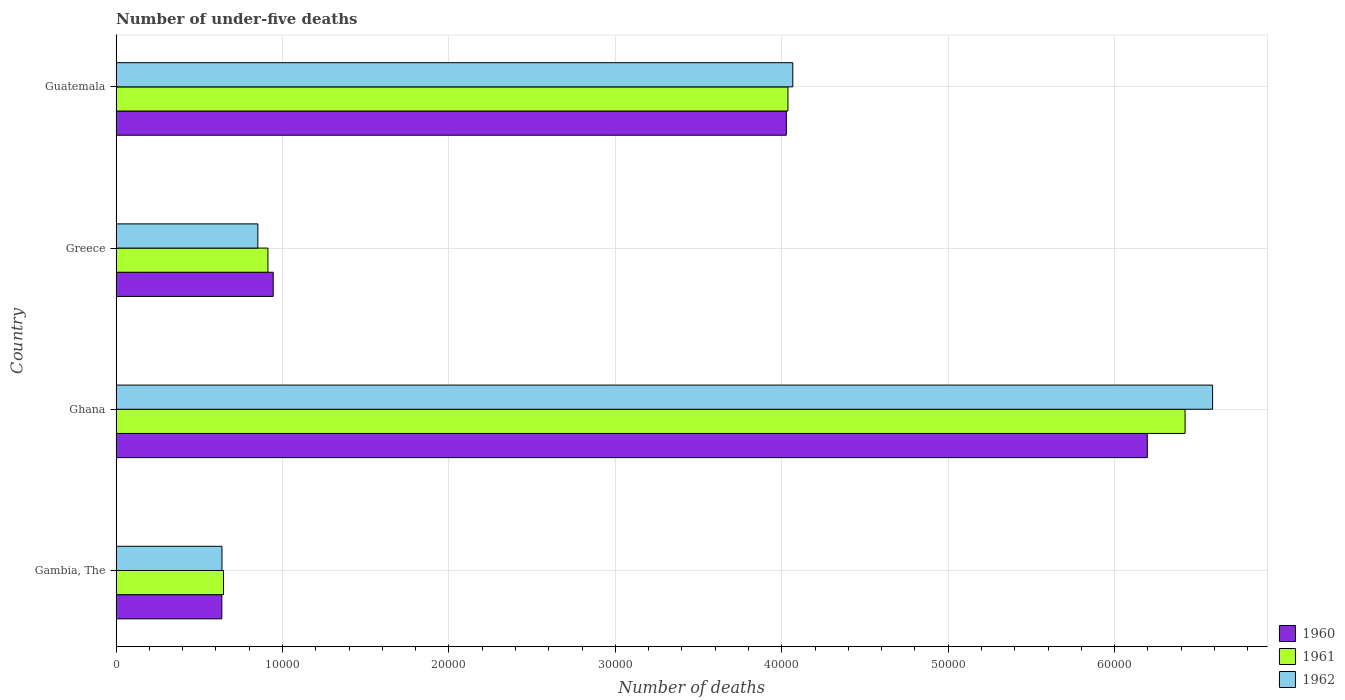How many bars are there on the 1st tick from the top?
Keep it short and to the point. 3. How many bars are there on the 3rd tick from the bottom?
Provide a succinct answer. 3. What is the label of the 1st group of bars from the top?
Your answer should be very brief. Guatemala. In how many cases, is the number of bars for a given country not equal to the number of legend labels?
Make the answer very short. 0. What is the number of under-five deaths in 1961 in Ghana?
Make the answer very short. 6.42e+04. Across all countries, what is the maximum number of under-five deaths in 1962?
Your response must be concise. 6.59e+04. Across all countries, what is the minimum number of under-five deaths in 1962?
Offer a terse response. 6361. In which country was the number of under-five deaths in 1960 minimum?
Your response must be concise. Gambia, The. What is the total number of under-five deaths in 1961 in the graph?
Provide a short and direct response. 1.20e+05. What is the difference between the number of under-five deaths in 1962 in Gambia, The and that in Ghana?
Make the answer very short. -5.95e+04. What is the difference between the number of under-five deaths in 1961 in Greece and the number of under-five deaths in 1960 in Guatemala?
Provide a succinct answer. -3.12e+04. What is the average number of under-five deaths in 1960 per country?
Ensure brevity in your answer.  2.95e+04. What is the difference between the number of under-five deaths in 1962 and number of under-five deaths in 1961 in Guatemala?
Make the answer very short. 291. What is the ratio of the number of under-five deaths in 1960 in Greece to that in Guatemala?
Keep it short and to the point. 0.23. Is the difference between the number of under-five deaths in 1962 in Gambia, The and Ghana greater than the difference between the number of under-five deaths in 1961 in Gambia, The and Ghana?
Provide a succinct answer. No. What is the difference between the highest and the second highest number of under-five deaths in 1962?
Offer a very short reply. 2.52e+04. What is the difference between the highest and the lowest number of under-five deaths in 1961?
Offer a terse response. 5.78e+04. Is the sum of the number of under-five deaths in 1960 in Ghana and Greece greater than the maximum number of under-five deaths in 1962 across all countries?
Your answer should be compact. Yes. Is it the case that in every country, the sum of the number of under-five deaths in 1962 and number of under-five deaths in 1960 is greater than the number of under-five deaths in 1961?
Keep it short and to the point. Yes. How many bars are there?
Offer a terse response. 12. Are all the bars in the graph horizontal?
Your answer should be compact. Yes. How many countries are there in the graph?
Ensure brevity in your answer.  4. What is the difference between two consecutive major ticks on the X-axis?
Make the answer very short. 10000. Are the values on the major ticks of X-axis written in scientific E-notation?
Offer a very short reply. No. Where does the legend appear in the graph?
Keep it short and to the point. Bottom right. How many legend labels are there?
Give a very brief answer. 3. How are the legend labels stacked?
Give a very brief answer. Vertical. What is the title of the graph?
Offer a very short reply. Number of under-five deaths. Does "1981" appear as one of the legend labels in the graph?
Keep it short and to the point. No. What is the label or title of the X-axis?
Offer a terse response. Number of deaths. What is the label or title of the Y-axis?
Keep it short and to the point. Country. What is the Number of deaths in 1960 in Gambia, The?
Your response must be concise. 6353. What is the Number of deaths in 1961 in Gambia, The?
Provide a succinct answer. 6452. What is the Number of deaths in 1962 in Gambia, The?
Keep it short and to the point. 6361. What is the Number of deaths in 1960 in Ghana?
Offer a terse response. 6.20e+04. What is the Number of deaths of 1961 in Ghana?
Offer a very short reply. 6.42e+04. What is the Number of deaths of 1962 in Ghana?
Offer a very short reply. 6.59e+04. What is the Number of deaths in 1960 in Greece?
Make the answer very short. 9439. What is the Number of deaths of 1961 in Greece?
Your answer should be compact. 9123. What is the Number of deaths of 1962 in Greece?
Make the answer very short. 8516. What is the Number of deaths of 1960 in Guatemala?
Make the answer very short. 4.03e+04. What is the Number of deaths in 1961 in Guatemala?
Provide a short and direct response. 4.04e+04. What is the Number of deaths of 1962 in Guatemala?
Your answer should be compact. 4.07e+04. Across all countries, what is the maximum Number of deaths of 1960?
Provide a short and direct response. 6.20e+04. Across all countries, what is the maximum Number of deaths of 1961?
Offer a very short reply. 6.42e+04. Across all countries, what is the maximum Number of deaths in 1962?
Offer a very short reply. 6.59e+04. Across all countries, what is the minimum Number of deaths in 1960?
Your answer should be very brief. 6353. Across all countries, what is the minimum Number of deaths of 1961?
Give a very brief answer. 6452. Across all countries, what is the minimum Number of deaths in 1962?
Offer a terse response. 6361. What is the total Number of deaths of 1960 in the graph?
Offer a very short reply. 1.18e+05. What is the total Number of deaths of 1961 in the graph?
Offer a terse response. 1.20e+05. What is the total Number of deaths in 1962 in the graph?
Your response must be concise. 1.21e+05. What is the difference between the Number of deaths in 1960 in Gambia, The and that in Ghana?
Offer a very short reply. -5.56e+04. What is the difference between the Number of deaths in 1961 in Gambia, The and that in Ghana?
Give a very brief answer. -5.78e+04. What is the difference between the Number of deaths of 1962 in Gambia, The and that in Ghana?
Keep it short and to the point. -5.95e+04. What is the difference between the Number of deaths in 1960 in Gambia, The and that in Greece?
Your response must be concise. -3086. What is the difference between the Number of deaths of 1961 in Gambia, The and that in Greece?
Make the answer very short. -2671. What is the difference between the Number of deaths in 1962 in Gambia, The and that in Greece?
Offer a terse response. -2155. What is the difference between the Number of deaths in 1960 in Gambia, The and that in Guatemala?
Provide a short and direct response. -3.39e+04. What is the difference between the Number of deaths in 1961 in Gambia, The and that in Guatemala?
Offer a very short reply. -3.39e+04. What is the difference between the Number of deaths in 1962 in Gambia, The and that in Guatemala?
Provide a short and direct response. -3.43e+04. What is the difference between the Number of deaths in 1960 in Ghana and that in Greece?
Make the answer very short. 5.25e+04. What is the difference between the Number of deaths of 1961 in Ghana and that in Greece?
Ensure brevity in your answer.  5.51e+04. What is the difference between the Number of deaths of 1962 in Ghana and that in Greece?
Your answer should be compact. 5.74e+04. What is the difference between the Number of deaths in 1960 in Ghana and that in Guatemala?
Your response must be concise. 2.17e+04. What is the difference between the Number of deaths in 1961 in Ghana and that in Guatemala?
Keep it short and to the point. 2.39e+04. What is the difference between the Number of deaths of 1962 in Ghana and that in Guatemala?
Give a very brief answer. 2.52e+04. What is the difference between the Number of deaths in 1960 in Greece and that in Guatemala?
Your response must be concise. -3.08e+04. What is the difference between the Number of deaths in 1961 in Greece and that in Guatemala?
Your answer should be compact. -3.12e+04. What is the difference between the Number of deaths in 1962 in Greece and that in Guatemala?
Offer a terse response. -3.21e+04. What is the difference between the Number of deaths in 1960 in Gambia, The and the Number of deaths in 1961 in Ghana?
Provide a succinct answer. -5.79e+04. What is the difference between the Number of deaths of 1960 in Gambia, The and the Number of deaths of 1962 in Ghana?
Keep it short and to the point. -5.95e+04. What is the difference between the Number of deaths of 1961 in Gambia, The and the Number of deaths of 1962 in Ghana?
Your answer should be very brief. -5.94e+04. What is the difference between the Number of deaths of 1960 in Gambia, The and the Number of deaths of 1961 in Greece?
Your answer should be very brief. -2770. What is the difference between the Number of deaths in 1960 in Gambia, The and the Number of deaths in 1962 in Greece?
Give a very brief answer. -2163. What is the difference between the Number of deaths of 1961 in Gambia, The and the Number of deaths of 1962 in Greece?
Offer a very short reply. -2064. What is the difference between the Number of deaths in 1960 in Gambia, The and the Number of deaths in 1961 in Guatemala?
Give a very brief answer. -3.40e+04. What is the difference between the Number of deaths in 1960 in Gambia, The and the Number of deaths in 1962 in Guatemala?
Provide a short and direct response. -3.43e+04. What is the difference between the Number of deaths of 1961 in Gambia, The and the Number of deaths of 1962 in Guatemala?
Ensure brevity in your answer.  -3.42e+04. What is the difference between the Number of deaths of 1960 in Ghana and the Number of deaths of 1961 in Greece?
Offer a very short reply. 5.28e+04. What is the difference between the Number of deaths in 1960 in Ghana and the Number of deaths in 1962 in Greece?
Make the answer very short. 5.34e+04. What is the difference between the Number of deaths in 1961 in Ghana and the Number of deaths in 1962 in Greece?
Provide a succinct answer. 5.57e+04. What is the difference between the Number of deaths of 1960 in Ghana and the Number of deaths of 1961 in Guatemala?
Your answer should be very brief. 2.16e+04. What is the difference between the Number of deaths in 1960 in Ghana and the Number of deaths in 1962 in Guatemala?
Keep it short and to the point. 2.13e+04. What is the difference between the Number of deaths in 1961 in Ghana and the Number of deaths in 1962 in Guatemala?
Offer a terse response. 2.36e+04. What is the difference between the Number of deaths of 1960 in Greece and the Number of deaths of 1961 in Guatemala?
Offer a terse response. -3.09e+04. What is the difference between the Number of deaths in 1960 in Greece and the Number of deaths in 1962 in Guatemala?
Your answer should be very brief. -3.12e+04. What is the difference between the Number of deaths in 1961 in Greece and the Number of deaths in 1962 in Guatemala?
Your answer should be compact. -3.15e+04. What is the average Number of deaths in 1960 per country?
Ensure brevity in your answer.  2.95e+04. What is the average Number of deaths in 1961 per country?
Your answer should be compact. 3.00e+04. What is the average Number of deaths of 1962 per country?
Offer a very short reply. 3.04e+04. What is the difference between the Number of deaths of 1960 and Number of deaths of 1961 in Gambia, The?
Your answer should be very brief. -99. What is the difference between the Number of deaths of 1960 and Number of deaths of 1962 in Gambia, The?
Your answer should be very brief. -8. What is the difference between the Number of deaths in 1961 and Number of deaths in 1962 in Gambia, The?
Your answer should be very brief. 91. What is the difference between the Number of deaths in 1960 and Number of deaths in 1961 in Ghana?
Keep it short and to the point. -2271. What is the difference between the Number of deaths in 1960 and Number of deaths in 1962 in Ghana?
Ensure brevity in your answer.  -3925. What is the difference between the Number of deaths in 1961 and Number of deaths in 1962 in Ghana?
Provide a succinct answer. -1654. What is the difference between the Number of deaths in 1960 and Number of deaths in 1961 in Greece?
Offer a terse response. 316. What is the difference between the Number of deaths in 1960 and Number of deaths in 1962 in Greece?
Your answer should be compact. 923. What is the difference between the Number of deaths of 1961 and Number of deaths of 1962 in Greece?
Your answer should be very brief. 607. What is the difference between the Number of deaths in 1960 and Number of deaths in 1961 in Guatemala?
Your answer should be very brief. -97. What is the difference between the Number of deaths of 1960 and Number of deaths of 1962 in Guatemala?
Make the answer very short. -388. What is the difference between the Number of deaths of 1961 and Number of deaths of 1962 in Guatemala?
Provide a short and direct response. -291. What is the ratio of the Number of deaths of 1960 in Gambia, The to that in Ghana?
Ensure brevity in your answer.  0.1. What is the ratio of the Number of deaths in 1961 in Gambia, The to that in Ghana?
Your answer should be very brief. 0.1. What is the ratio of the Number of deaths in 1962 in Gambia, The to that in Ghana?
Provide a succinct answer. 0.1. What is the ratio of the Number of deaths of 1960 in Gambia, The to that in Greece?
Offer a terse response. 0.67. What is the ratio of the Number of deaths of 1961 in Gambia, The to that in Greece?
Make the answer very short. 0.71. What is the ratio of the Number of deaths of 1962 in Gambia, The to that in Greece?
Keep it short and to the point. 0.75. What is the ratio of the Number of deaths of 1960 in Gambia, The to that in Guatemala?
Give a very brief answer. 0.16. What is the ratio of the Number of deaths of 1961 in Gambia, The to that in Guatemala?
Make the answer very short. 0.16. What is the ratio of the Number of deaths of 1962 in Gambia, The to that in Guatemala?
Keep it short and to the point. 0.16. What is the ratio of the Number of deaths of 1960 in Ghana to that in Greece?
Provide a short and direct response. 6.56. What is the ratio of the Number of deaths of 1961 in Ghana to that in Greece?
Ensure brevity in your answer.  7.04. What is the ratio of the Number of deaths of 1962 in Ghana to that in Greece?
Give a very brief answer. 7.74. What is the ratio of the Number of deaths of 1960 in Ghana to that in Guatemala?
Make the answer very short. 1.54. What is the ratio of the Number of deaths in 1961 in Ghana to that in Guatemala?
Make the answer very short. 1.59. What is the ratio of the Number of deaths in 1962 in Ghana to that in Guatemala?
Keep it short and to the point. 1.62. What is the ratio of the Number of deaths in 1960 in Greece to that in Guatemala?
Give a very brief answer. 0.23. What is the ratio of the Number of deaths in 1961 in Greece to that in Guatemala?
Ensure brevity in your answer.  0.23. What is the ratio of the Number of deaths in 1962 in Greece to that in Guatemala?
Keep it short and to the point. 0.21. What is the difference between the highest and the second highest Number of deaths of 1960?
Give a very brief answer. 2.17e+04. What is the difference between the highest and the second highest Number of deaths in 1961?
Provide a short and direct response. 2.39e+04. What is the difference between the highest and the second highest Number of deaths in 1962?
Provide a succinct answer. 2.52e+04. What is the difference between the highest and the lowest Number of deaths in 1960?
Provide a succinct answer. 5.56e+04. What is the difference between the highest and the lowest Number of deaths in 1961?
Your answer should be very brief. 5.78e+04. What is the difference between the highest and the lowest Number of deaths in 1962?
Offer a terse response. 5.95e+04. 